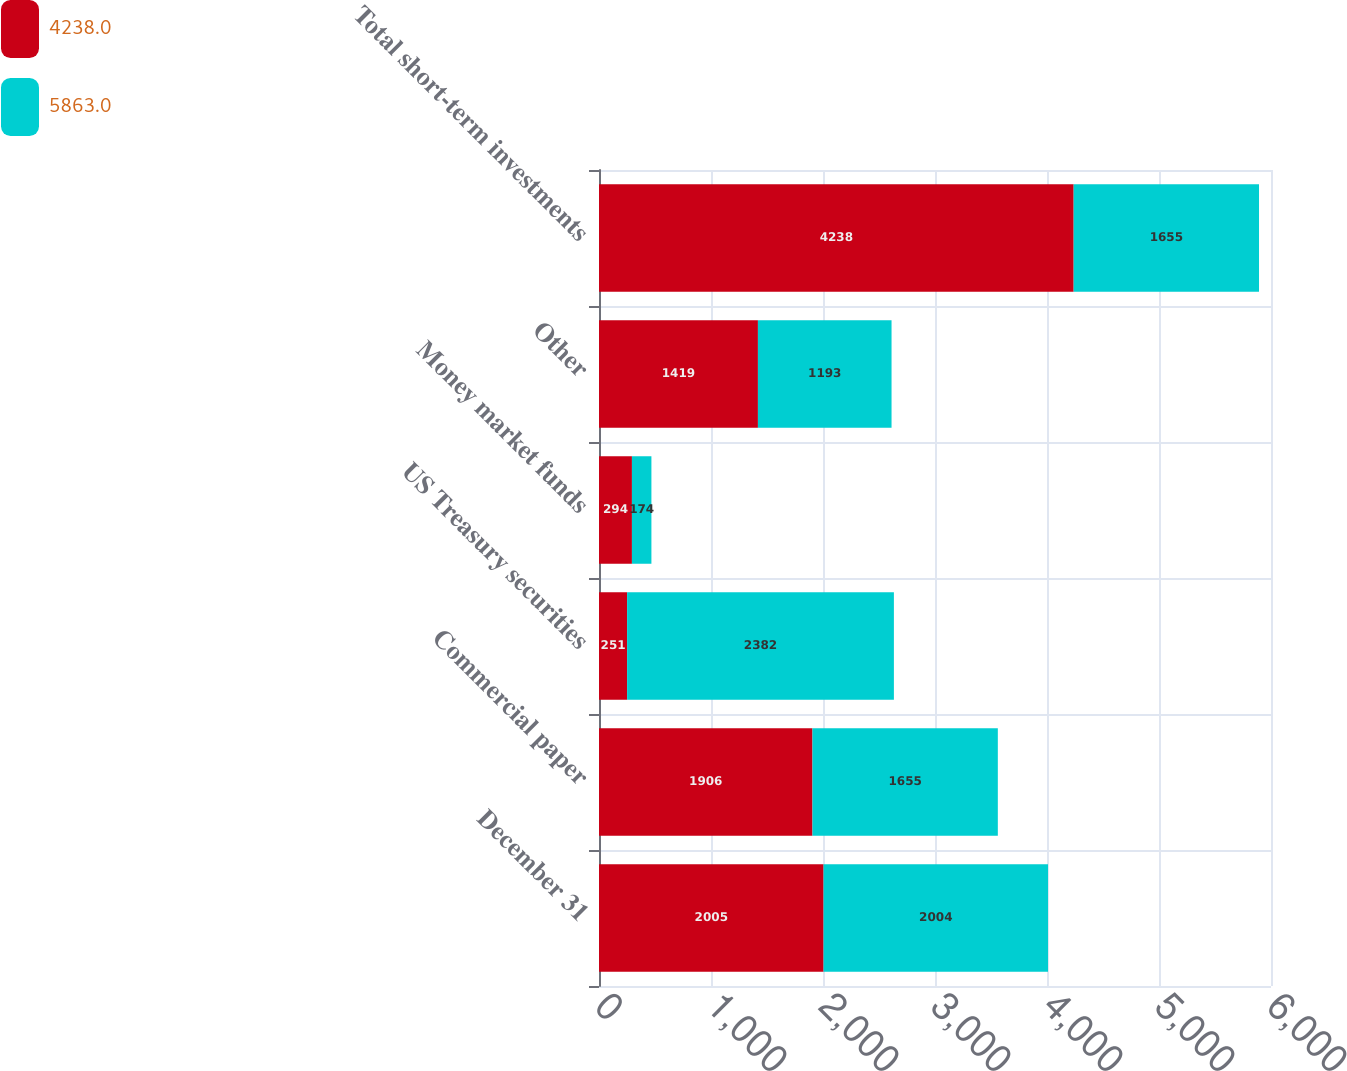Convert chart. <chart><loc_0><loc_0><loc_500><loc_500><stacked_bar_chart><ecel><fcel>December 31<fcel>Commercial paper<fcel>US Treasury securities<fcel>Money market funds<fcel>Other<fcel>Total short-term investments<nl><fcel>4238<fcel>2005<fcel>1906<fcel>251<fcel>294<fcel>1419<fcel>4238<nl><fcel>5863<fcel>2004<fcel>1655<fcel>2382<fcel>174<fcel>1193<fcel>1655<nl></chart> 